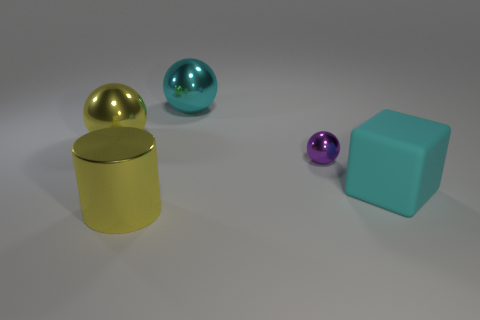Are there any other things that are the same size as the purple object?
Ensure brevity in your answer.  No. Is there anything else that is made of the same material as the big block?
Your response must be concise. No. There is a yellow thing in front of the small purple metal sphere; how big is it?
Provide a succinct answer. Large. Is there a purple sphere to the right of the big cyan object in front of the purple shiny ball?
Your answer should be compact. No. What number of other objects are the same shape as the purple thing?
Offer a very short reply. 2. Does the big cyan metallic thing have the same shape as the tiny metal object?
Provide a short and direct response. Yes. What color is the thing that is in front of the purple shiny sphere and on the right side of the big cyan shiny object?
Provide a short and direct response. Cyan. What size is the metallic ball that is the same color as the cylinder?
Keep it short and to the point. Large. What number of big things are either matte objects or cyan spheres?
Offer a terse response. 2. Is there any other thing that has the same color as the small metallic thing?
Offer a terse response. No. 